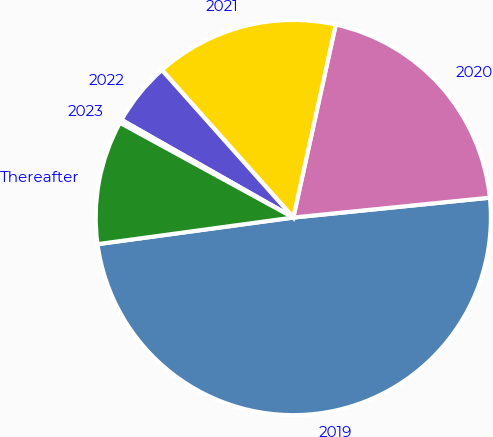<chart> <loc_0><loc_0><loc_500><loc_500><pie_chart><fcel>2019<fcel>2020<fcel>2021<fcel>2022<fcel>2023<fcel>Thereafter<nl><fcel>49.45%<fcel>19.95%<fcel>15.03%<fcel>5.19%<fcel>0.27%<fcel>10.11%<nl></chart> 